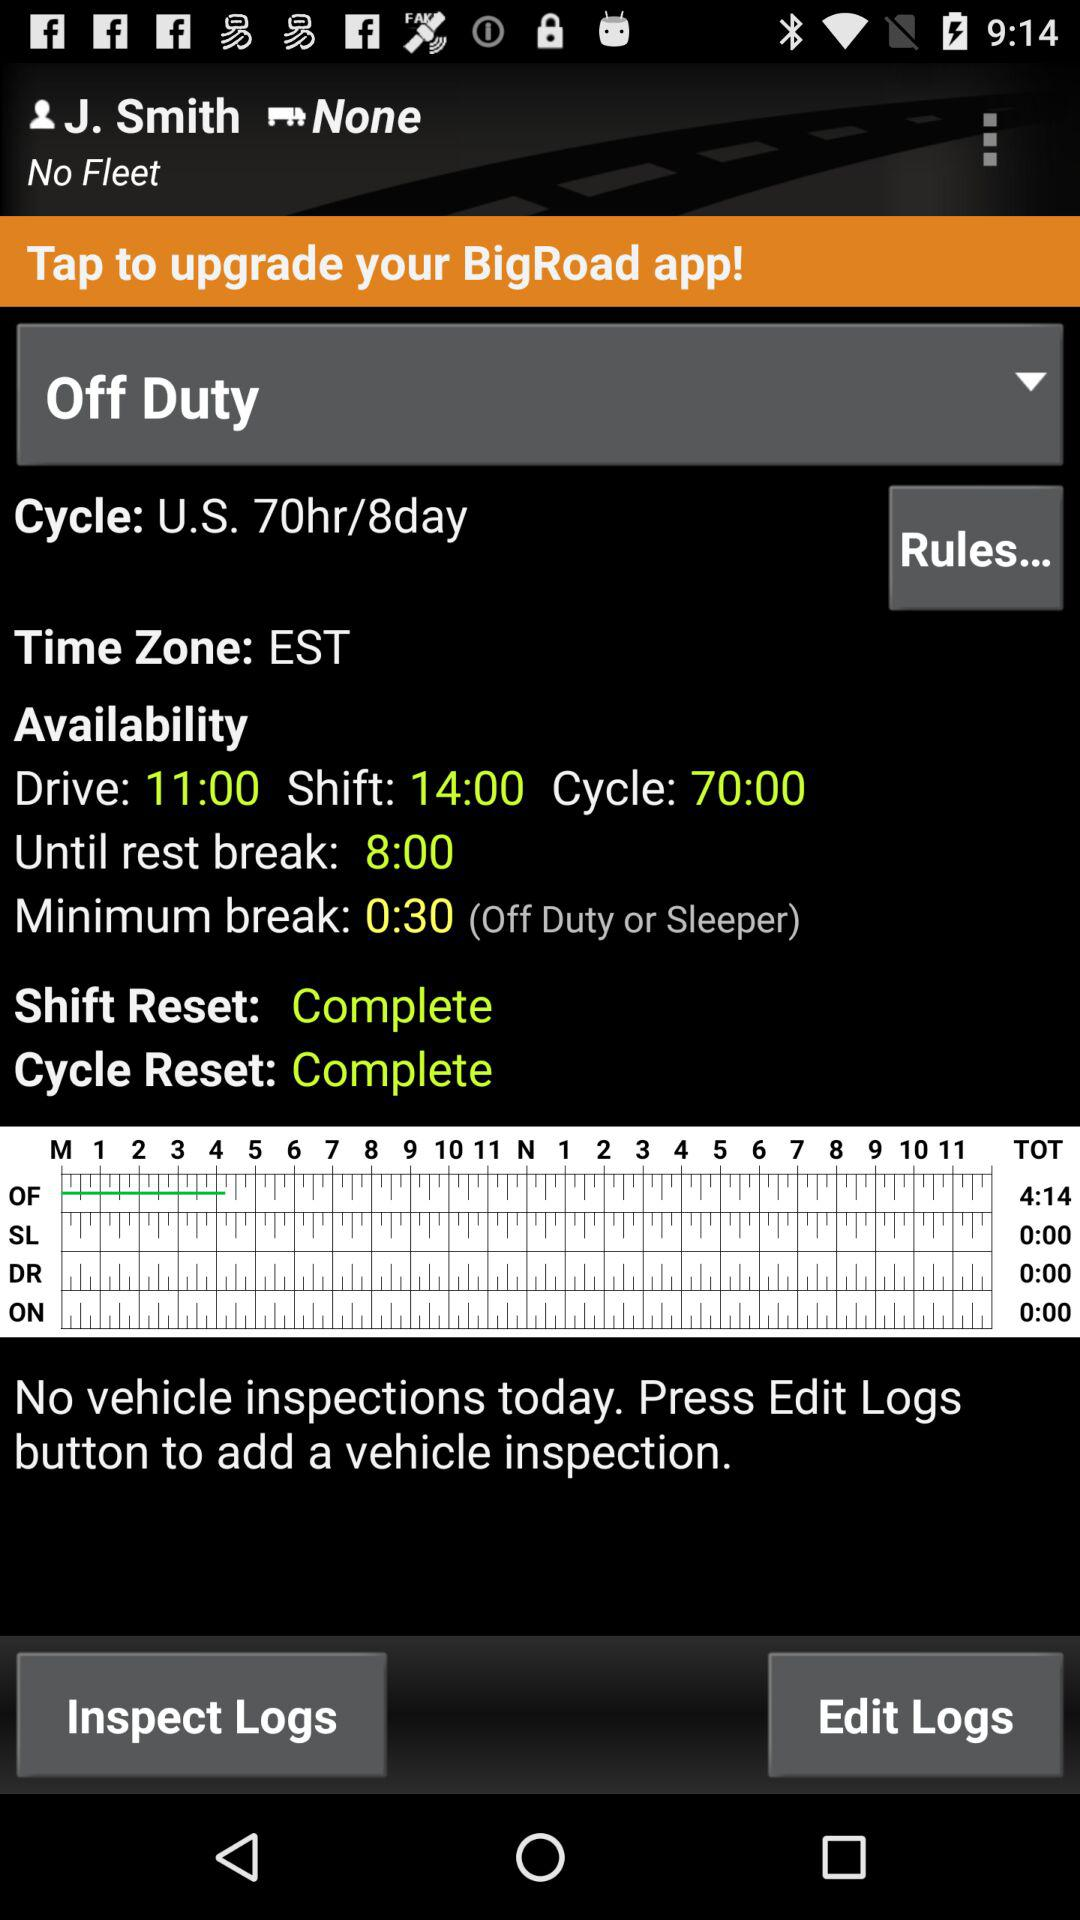What is the user name? The user name is J. Smith. 